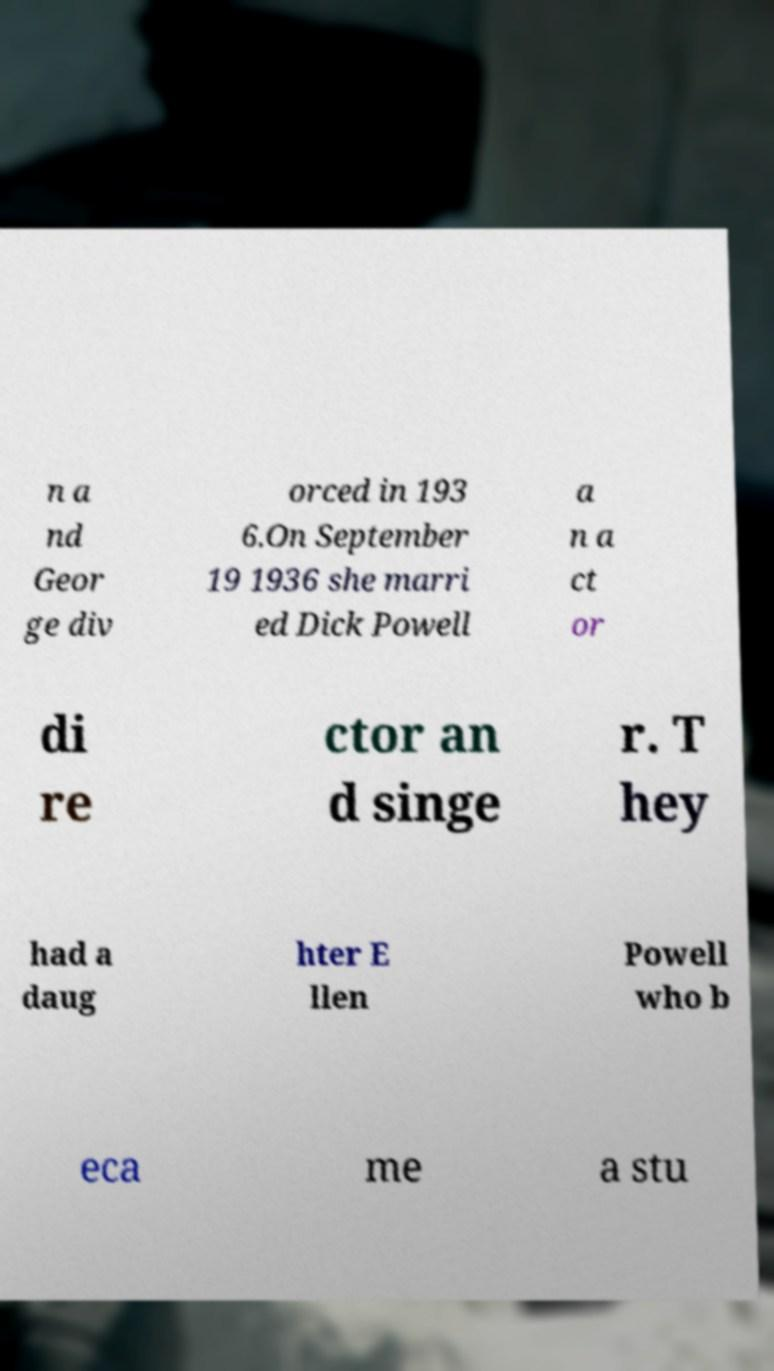For documentation purposes, I need the text within this image transcribed. Could you provide that? n a nd Geor ge div orced in 193 6.On September 19 1936 she marri ed Dick Powell a n a ct or di re ctor an d singe r. T hey had a daug hter E llen Powell who b eca me a stu 